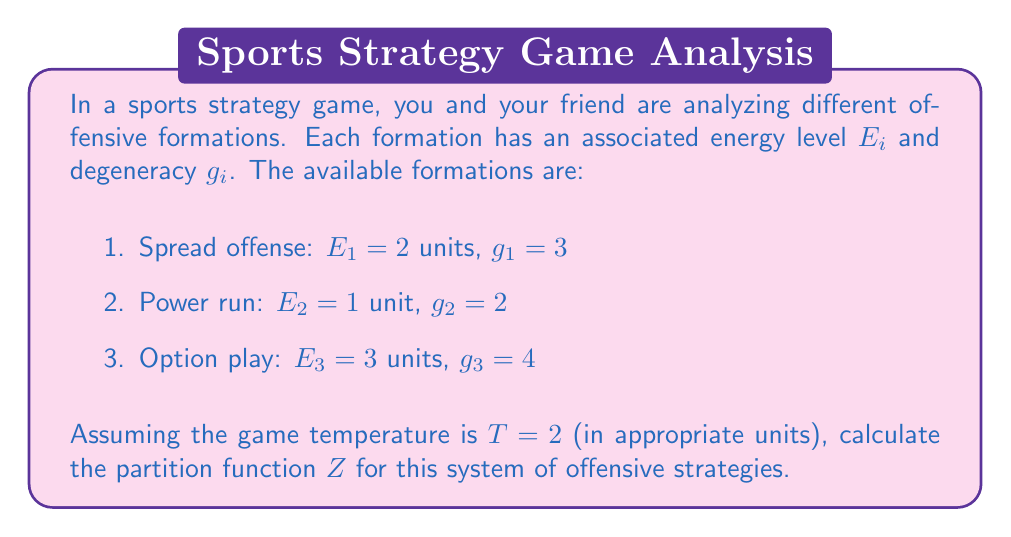Provide a solution to this math problem. To solve this problem, we'll follow these steps:

1. Recall the formula for the partition function:
   $$Z = \sum_i g_i e^{-\beta E_i}$$
   where $\beta = \frac{1}{k_B T}$, and $k_B$ is Boltzmann's constant (which we'll assume is 1 for simplicity).

2. Calculate $\beta$:
   $$\beta = \frac{1}{T} = \frac{1}{2}$$

3. Now, let's calculate the contribution of each formation to the partition function:

   For spread offense:
   $$g_1 e^{-\beta E_1} = 3 e^{-\frac{1}{2} \cdot 2} = 3 e^{-1} = \frac{3}{e}$$

   For power run:
   $$g_2 e^{-\beta E_2} = 2 e^{-\frac{1}{2} \cdot 1} = 2 e^{-\frac{1}{2}} = 2\sqrt{e}$$

   For option play:
   $$g_3 e^{-\beta E_3} = 4 e^{-\frac{1}{2} \cdot 3} = 4 e^{-\frac{3}{2}} = \frac{4}{e\sqrt{e}}$$

4. Sum up all contributions to get the partition function:
   $$Z = \frac{3}{e} + 2\sqrt{e} + \frac{4}{e\sqrt{e}}$$

5. Simplify the expression:
   $$Z = \frac{3}{e} + 2e^{\frac{1}{2}} + 4e^{-\frac{3}{2}}$$

This is the final form of the partition function for the given system of offensive strategies.
Answer: $$Z = \frac{3}{e} + 2e^{\frac{1}{2}} + 4e^{-\frac{3}{2}}$$ 